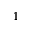<formula> <loc_0><loc_0><loc_500><loc_500>1</formula> 